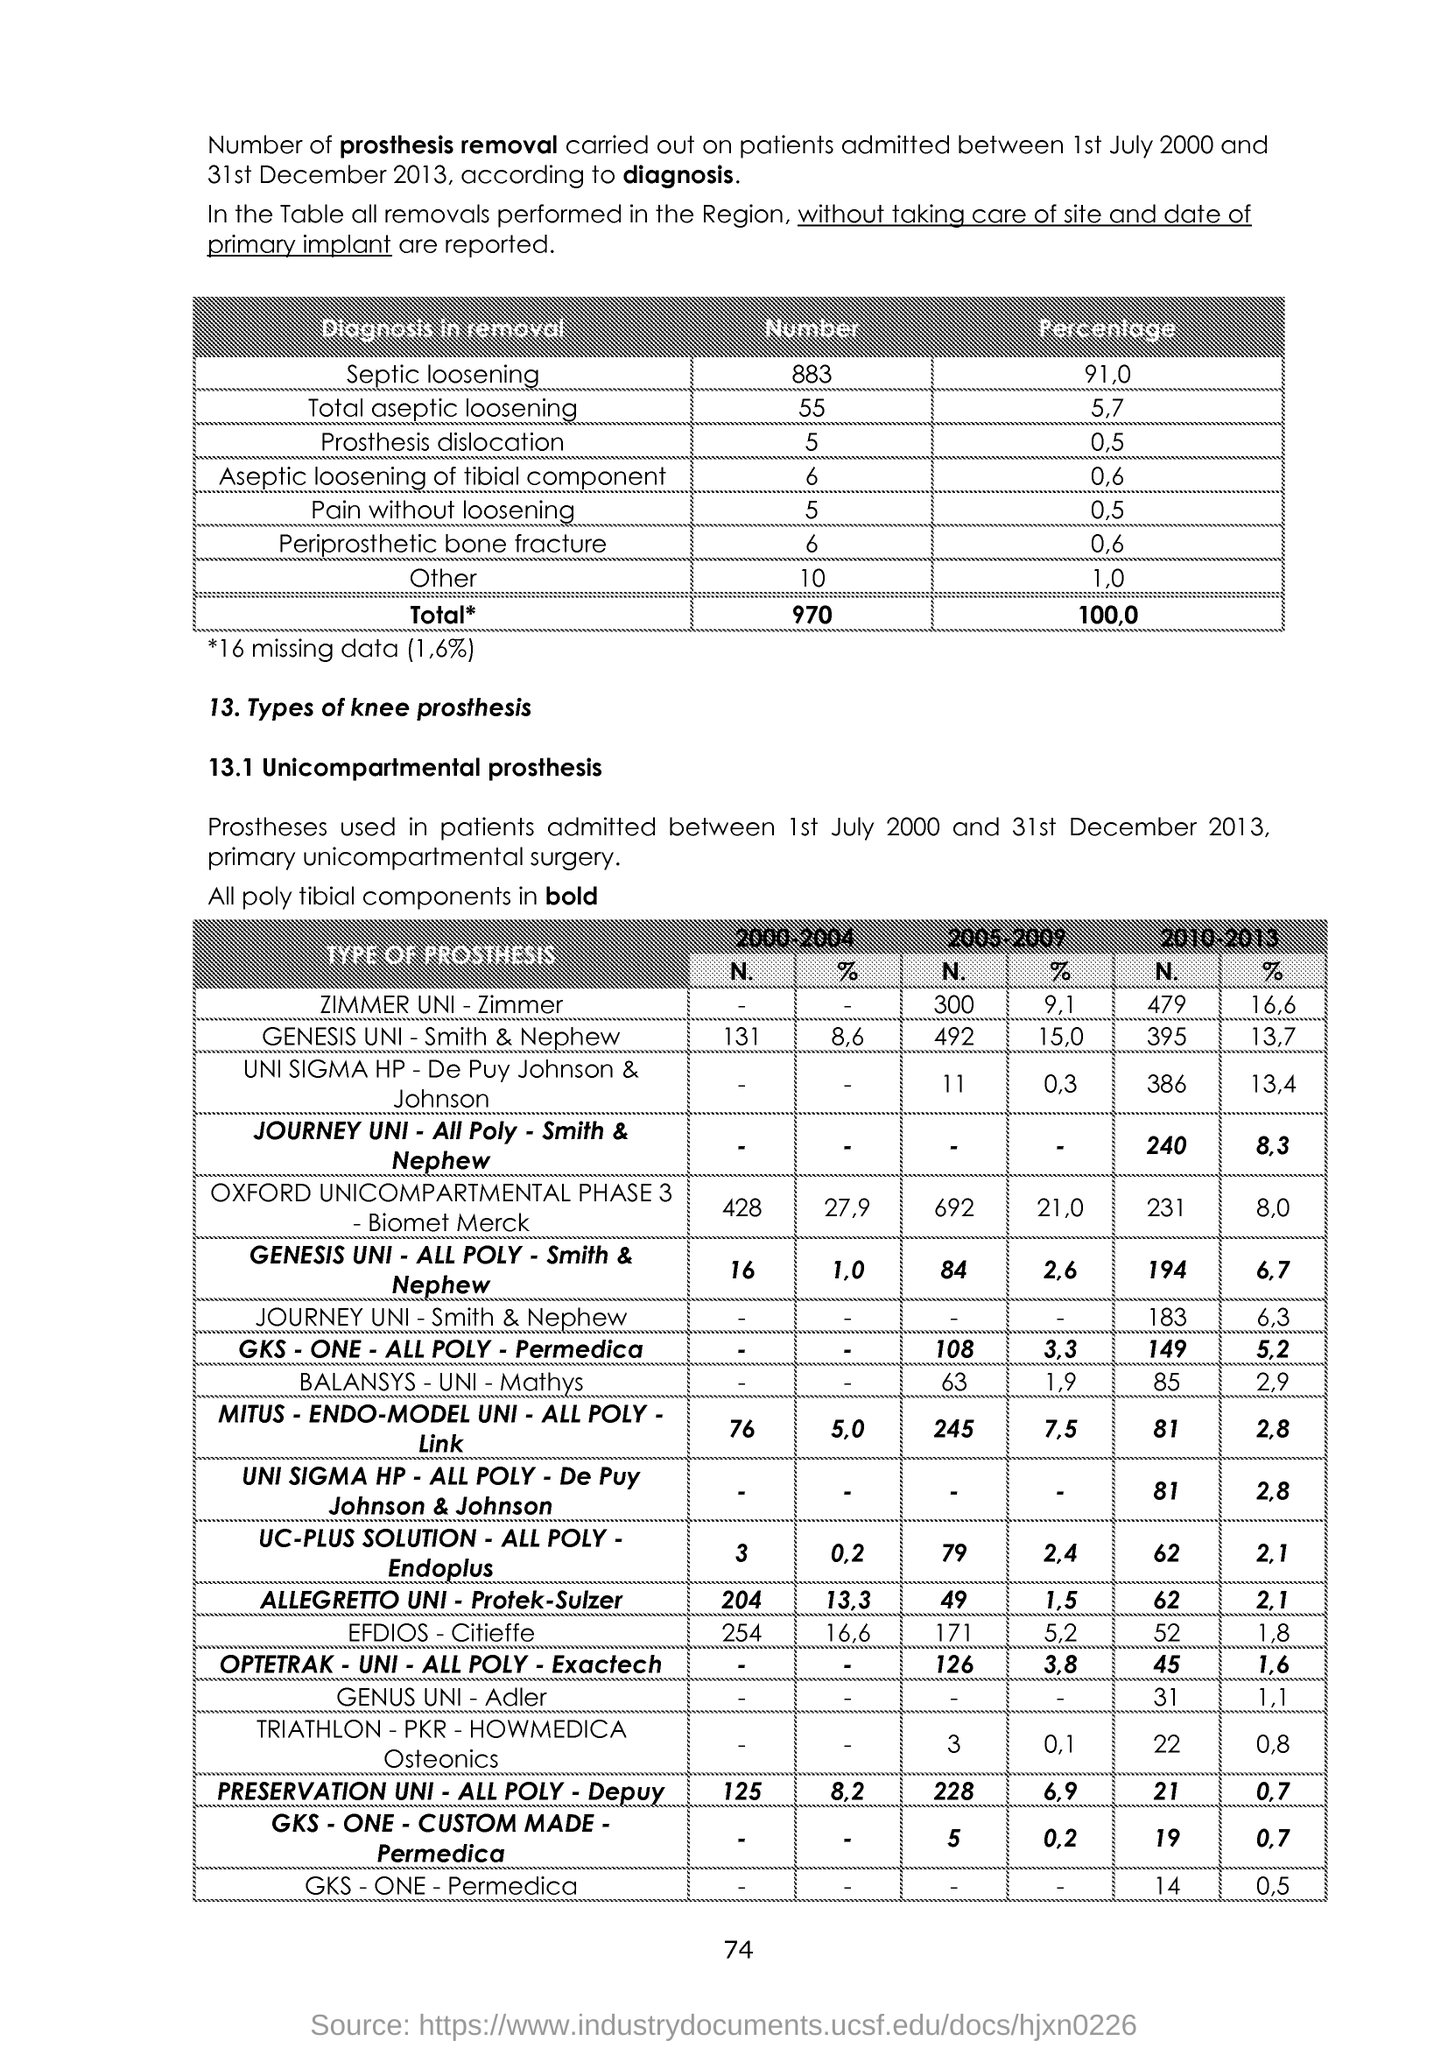Mention a couple of crucial points in this snapshot. The page number is 74. 